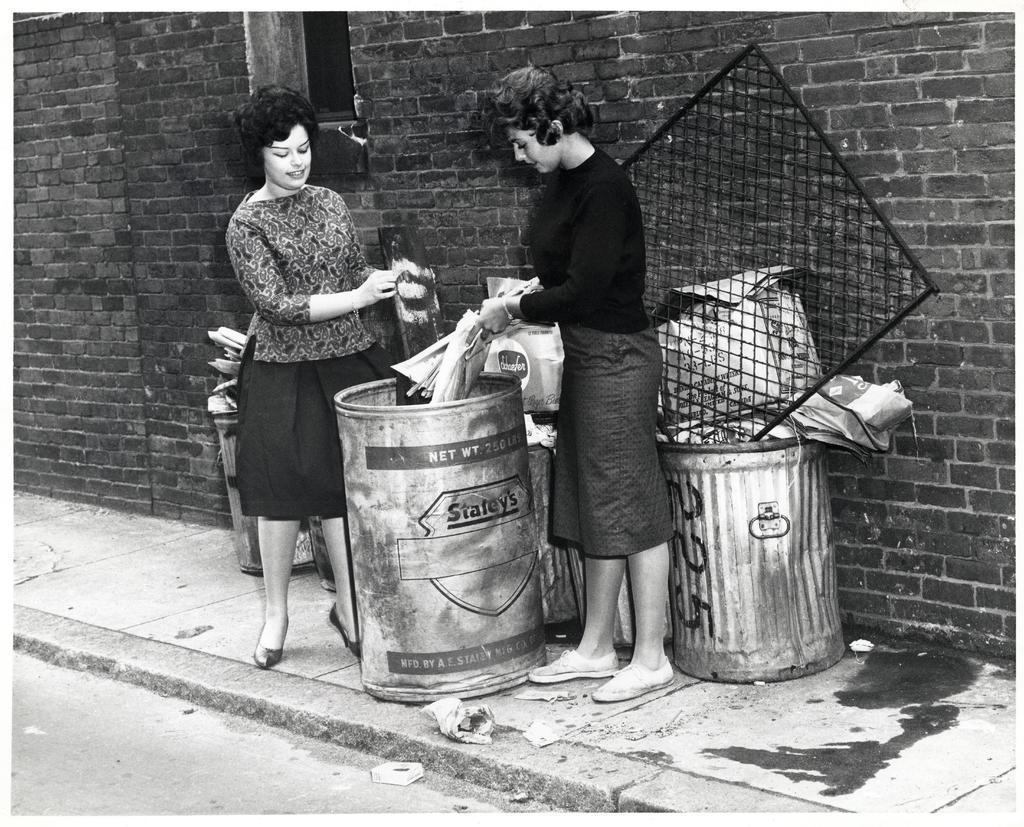<image>
Give a short and clear explanation of the subsequent image. Two woman are dumping trash into a barrel that says Statey's in an alley. 